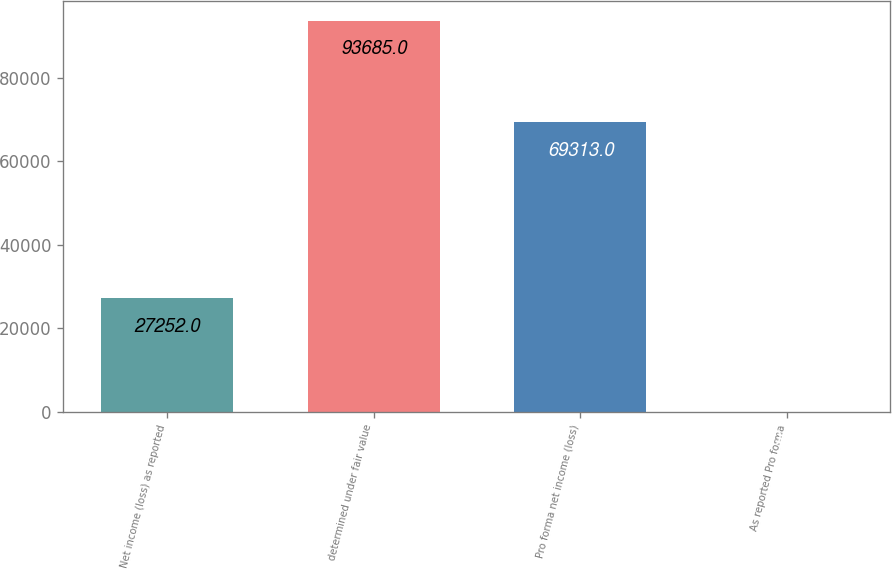Convert chart to OTSL. <chart><loc_0><loc_0><loc_500><loc_500><bar_chart><fcel>Net income (loss) as reported<fcel>determined under fair value<fcel>Pro forma net income (loss)<fcel>As reported Pro forma<nl><fcel>27252<fcel>93685<fcel>69313<fcel>0.28<nl></chart> 